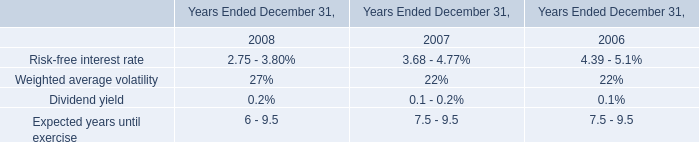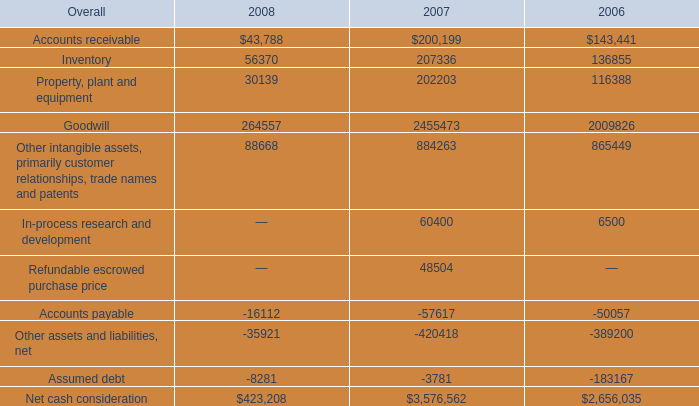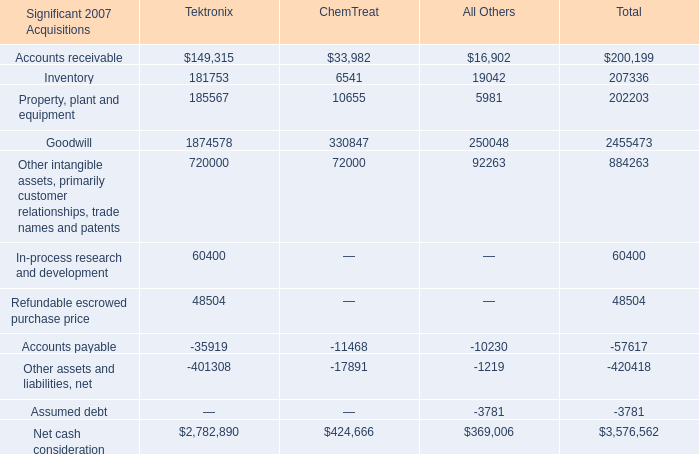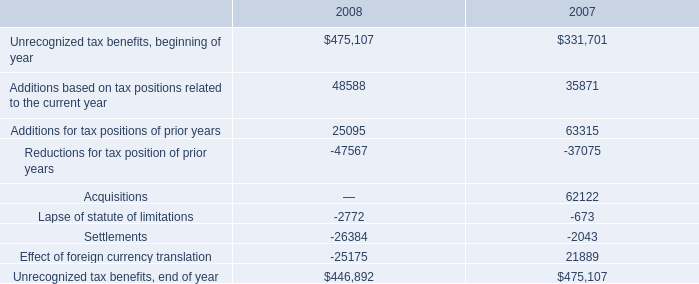What's the sum of all Accounts receivable that are greater than 100000 in 2007? (in dollars) 
Answer: 149315. 